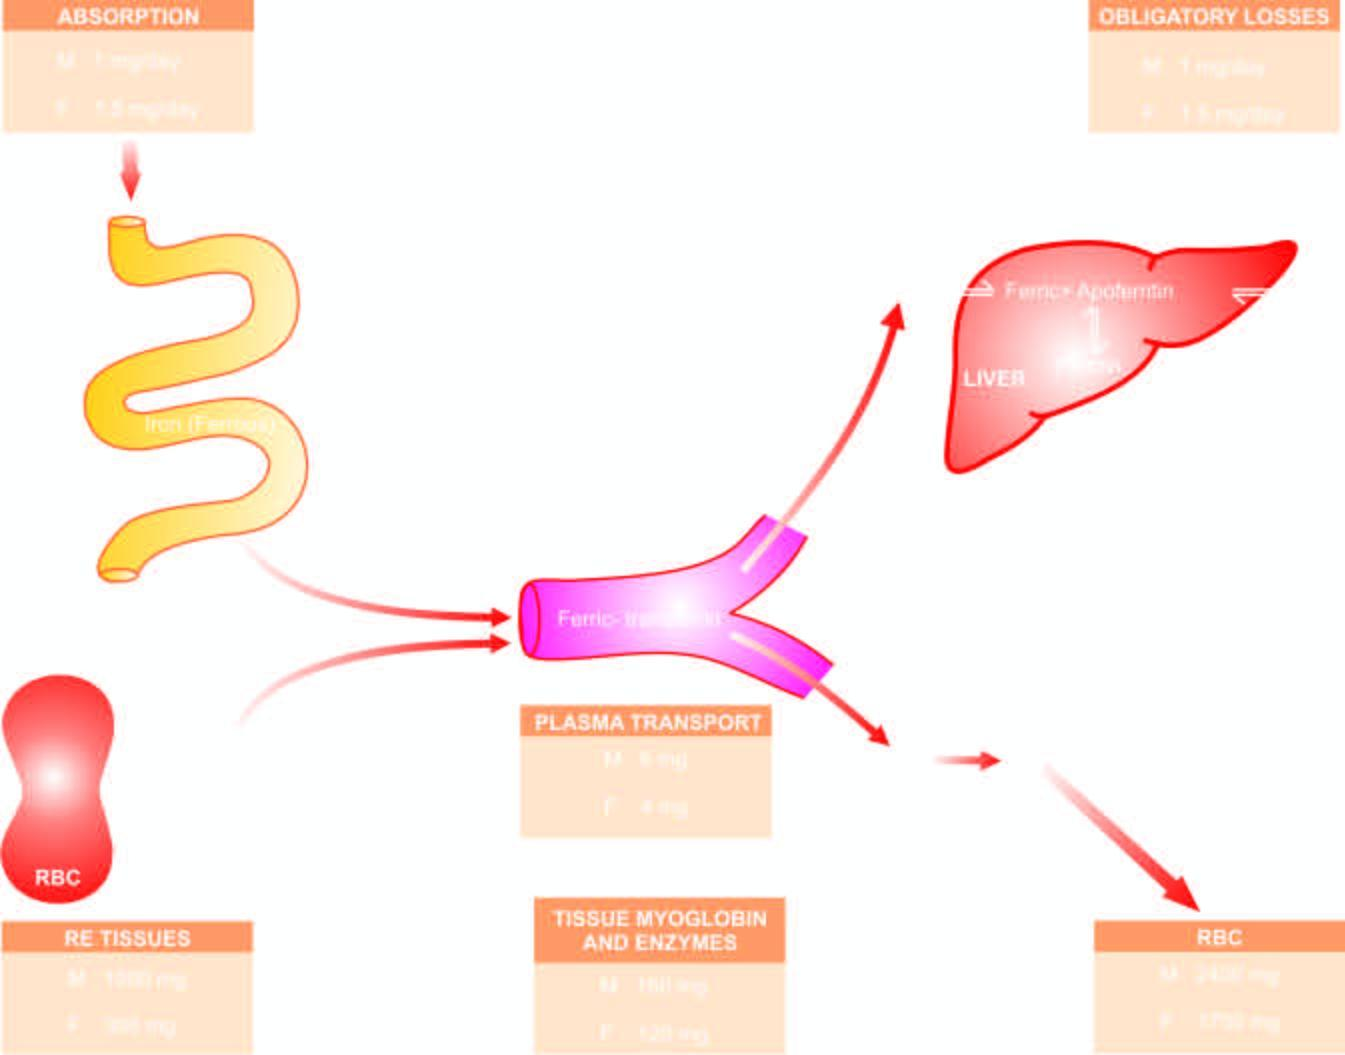what is mobilised in response to increased demand and used for haemoglobin synthesis, thus completing the cycle m = males ; f = females?
Answer the question using a single word or phrase. Iron 